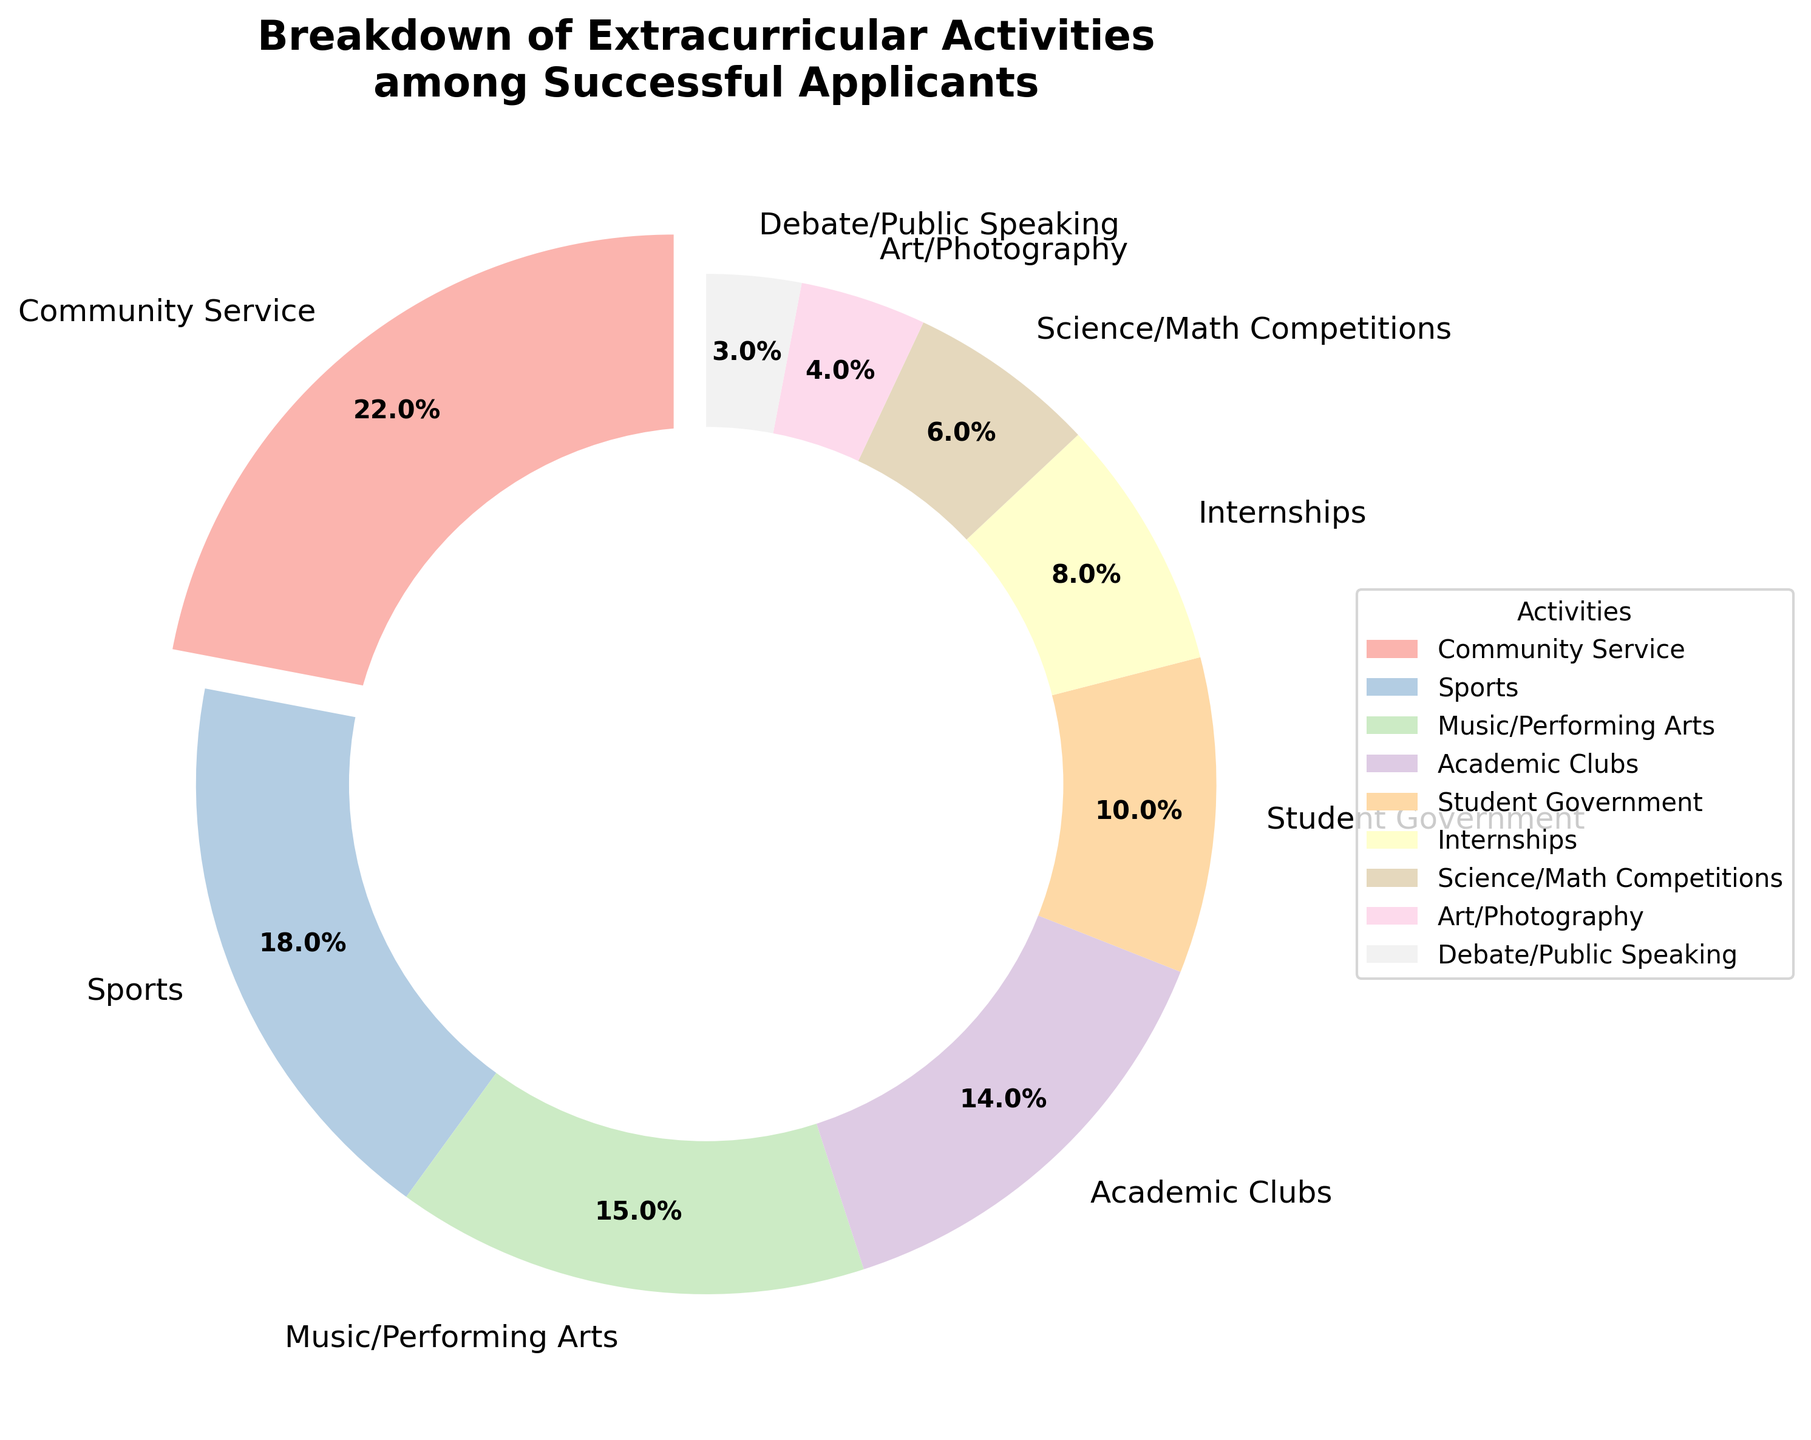What activity makes up the largest percentage of extracurricular activities among successful applicants? The activity with the largest percentage will be the one with the biggest slice of the pie chart and exploded outwards slightly. Here, "Community Service" occupies 22%.
Answer: Community Service Which activities together make up over 50% of the pie chart? Sum of percentages: Community Service (22%) + Sports (18%) + Music/Performing Arts (15%) = 55%, which is over 50%.
Answer: Community Service, Sports, Music/Performing Arts Which activity comprises only 3% of the extracurricular activities? The smallest slice, labelled "Debate/Public Speaking," represents only 3% of the total.
Answer: Debate/Public Speaking How does the percentage of Academic Clubs compare to Internships? Find the slices labeled "Academic Clubs" (14%) and "Internships" (8%). Since 14% is greater than 8%, Academic Clubs are more represented than Internships.
Answer: Academic Clubs have a higher percentage than Internships Are there more applicants involved in Art/Photography or Science/Math Competitions? Compare the percentages for "Art/Photography" (4%) and "Science/Math Competitions" (6%). Since 6% > 4%, more applicants are involved in Science/Math Competitions.
Answer: Science/Math Competitions What is the combined percentage of Student Government and Internships? Add the percentages: Student Government (10%) + Internships (8%) = 18%.
Answer: 18% Does Music/Performing Arts have a higher percentage than Sports? Compare the percentages for Music/Performing Arts (15%) and Sports (18%). Since 15% < 18%, Music/Performing Arts has a lower percentage than Sports.
Answer: No Which activity represents twice the percentage of Debate/Public Speaking? The slice labeled "Music/Performing Arts" has 15%, which is five times the 3% of "Debate/Public Speaking".
Answer: None What is the median value of the listed extracurricular activities? Sort the percentages in increasing order: 3%, 4%, 6%, 8%, 10%, 14%, 15%, 18%, 22%. The middle value (5th in the sorted list) is 10%. Thus, the median value is 10%.
Answer: 10% 